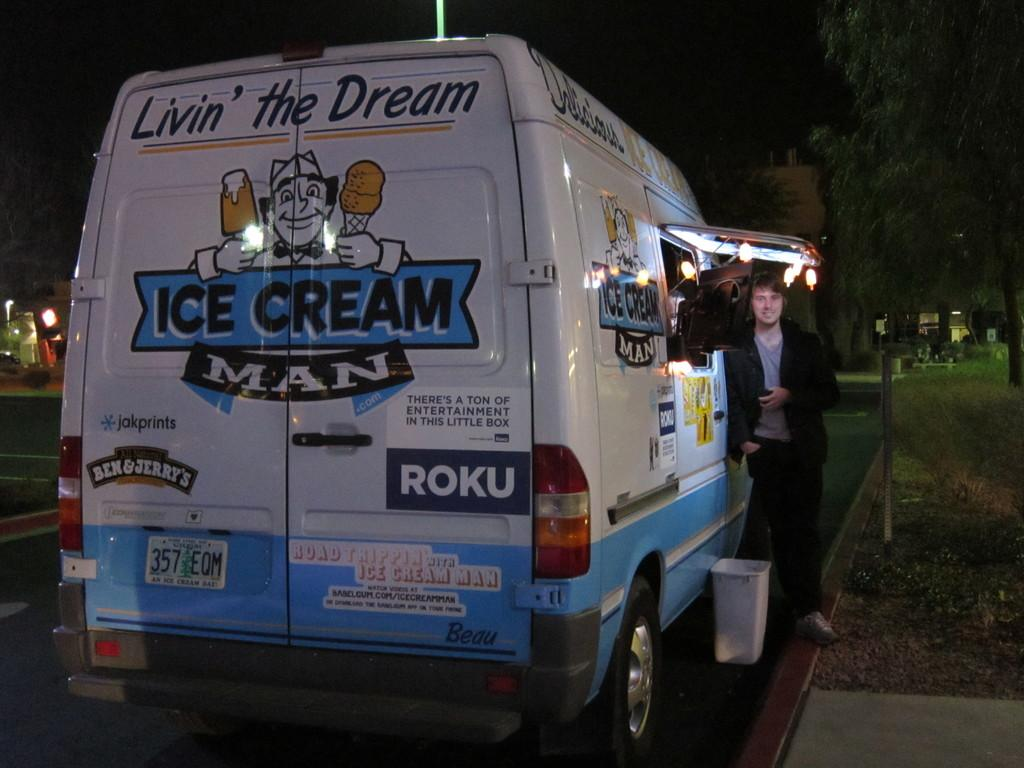<image>
Relay a brief, clear account of the picture shown. the back of an ICE CREAM MAN van 